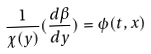<formula> <loc_0><loc_0><loc_500><loc_500>\frac { 1 } { \chi ( y ) } ( \frac { d \beta } { d y } ) = \phi ( t , x )</formula> 